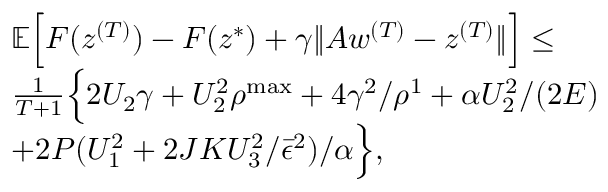<formula> <loc_0><loc_0><loc_500><loc_500>\begin{array} { r l } & { \mathbb { E } \left [ F ( z ^ { ( T ) } ) - F ( z ^ { * } ) + \gamma \| A w ^ { ( T ) } - z ^ { ( T ) } \| \right ] \leq } \\ & { \frac { 1 } { T + 1 } \left \{ 2 U _ { 2 } \gamma + U _ { 2 } ^ { 2 } \rho ^ { \max } + 4 \gamma ^ { 2 } / \rho ^ { 1 } + \alpha U _ { 2 } ^ { 2 } / ( 2 E ) } \\ & { + 2 P ( U _ { 1 } ^ { 2 } + 2 J K U _ { 3 } ^ { 2 } / \bar { \epsilon } ^ { 2 } ) / \alpha \right \} , } \end{array}</formula> 